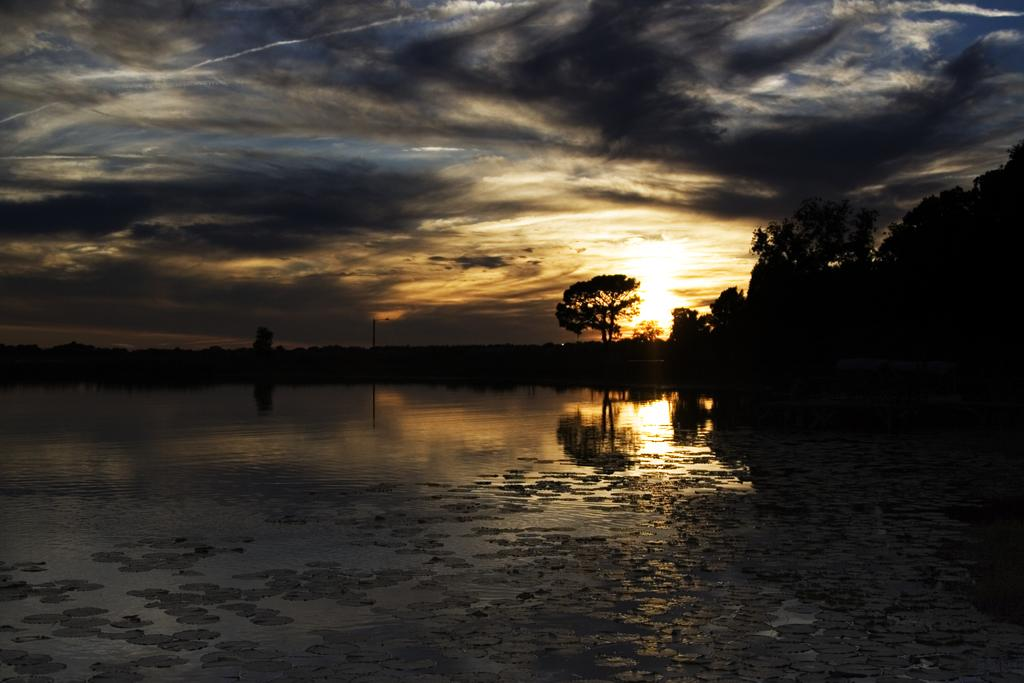What is visible in the image? Water is visible in the image. What can be seen in the background of the image? There is a pole, many trees, clouds, and the sky visible in the background of the image. How many girls are playing with the cactus in the image? There are no girls or cactus present in the image. What type of boats can be seen sailing in the water? There are no boats visible in the image; only water, a pole, trees, clouds, and the sky are present. 